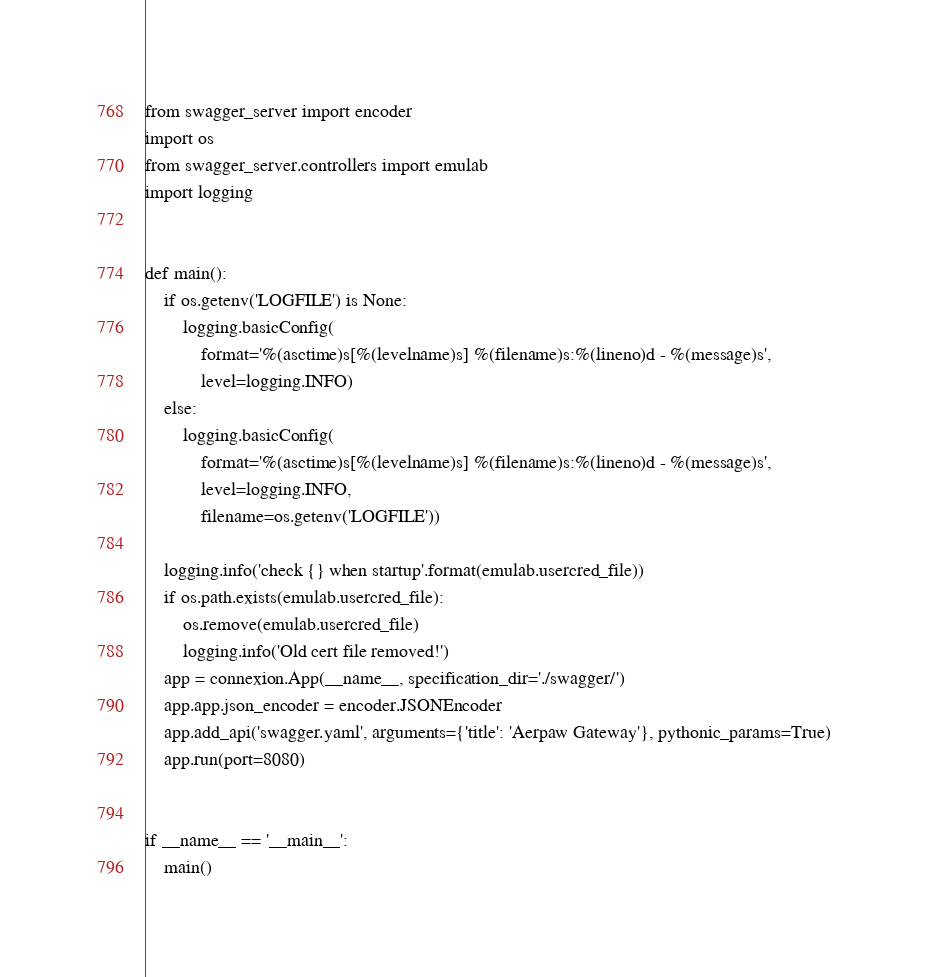Convert code to text. <code><loc_0><loc_0><loc_500><loc_500><_Python_>
from swagger_server import encoder
import os
from swagger_server.controllers import emulab
import logging


def main():
    if os.getenv('LOGFILE') is None:
        logging.basicConfig(
            format='%(asctime)s[%(levelname)s] %(filename)s:%(lineno)d - %(message)s',
            level=logging.INFO)
    else:
        logging.basicConfig(
            format='%(asctime)s[%(levelname)s] %(filename)s:%(lineno)d - %(message)s',
            level=logging.INFO,
            filename=os.getenv('LOGFILE'))

    logging.info('check {} when startup'.format(emulab.usercred_file))
    if os.path.exists(emulab.usercred_file):
        os.remove(emulab.usercred_file)
        logging.info('Old cert file removed!')
    app = connexion.App(__name__, specification_dir='./swagger/')
    app.app.json_encoder = encoder.JSONEncoder
    app.add_api('swagger.yaml', arguments={'title': 'Aerpaw Gateway'}, pythonic_params=True)
    app.run(port=8080)


if __name__ == '__main__':
    main()
</code> 